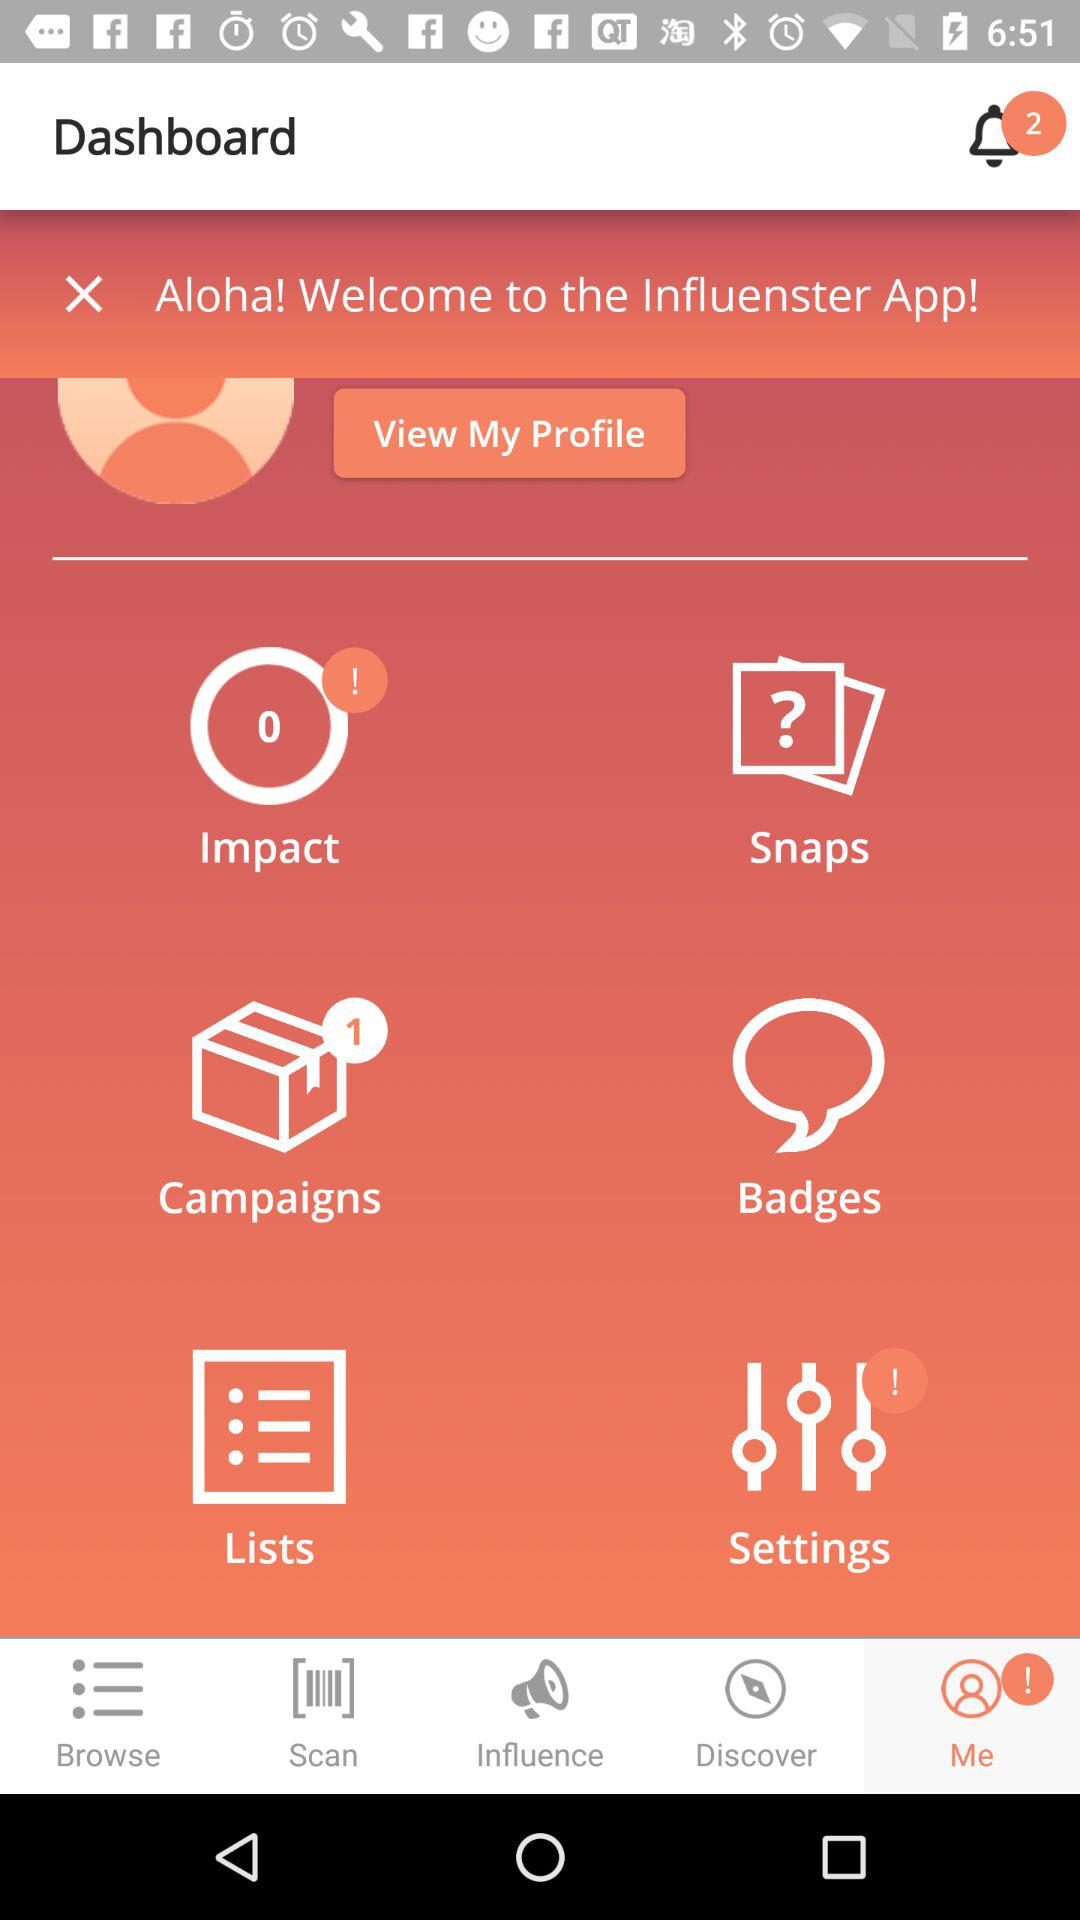Which tab is selected for the dashboard? The selected tab is "Me". 